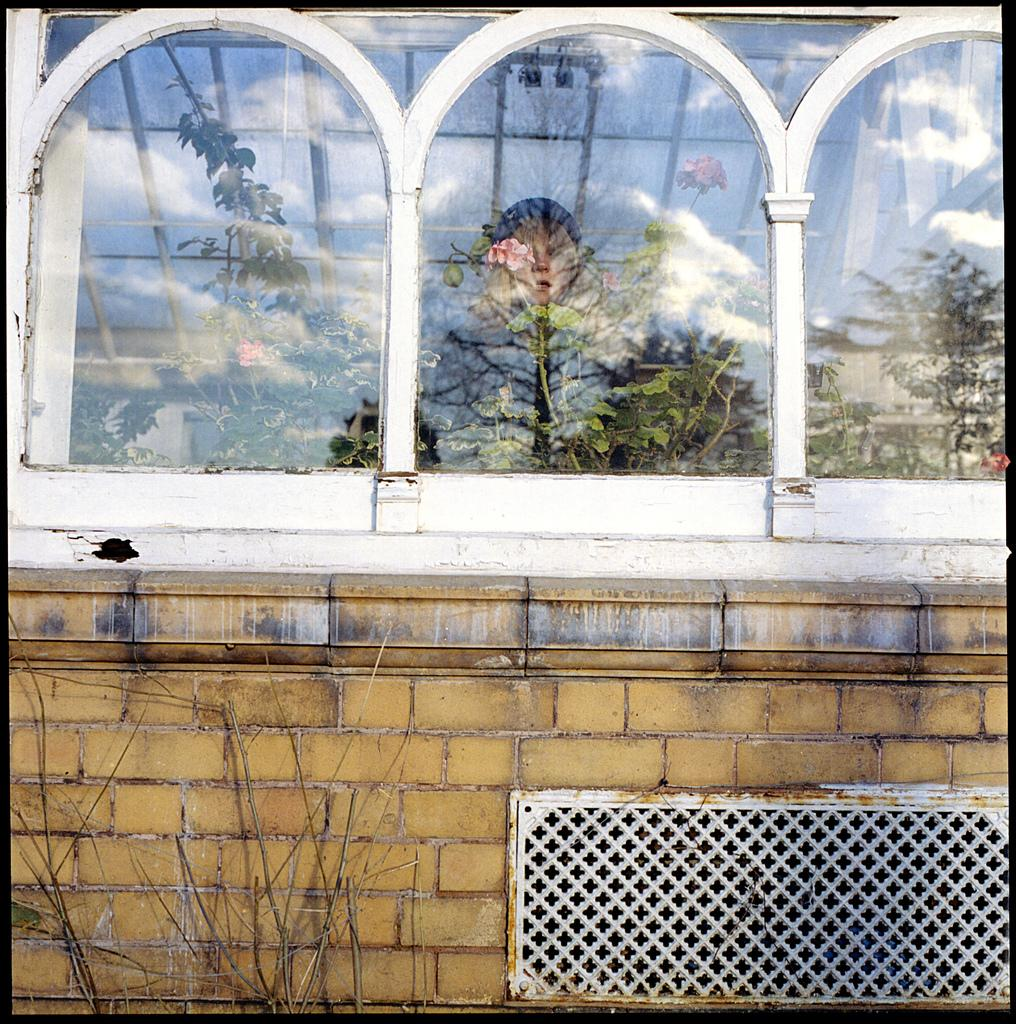What type of structure is present in the image? There is a building in the image. What feature can be seen on the building? The building has a window. Can you describe the person visible inside the building? There is a person visible inside the building. What is located next to the building? There is a dried plant next to the building. What statement does the mailbox make about the season in the image? There is no mailbox present in the image, so it cannot make any statement about the season. 